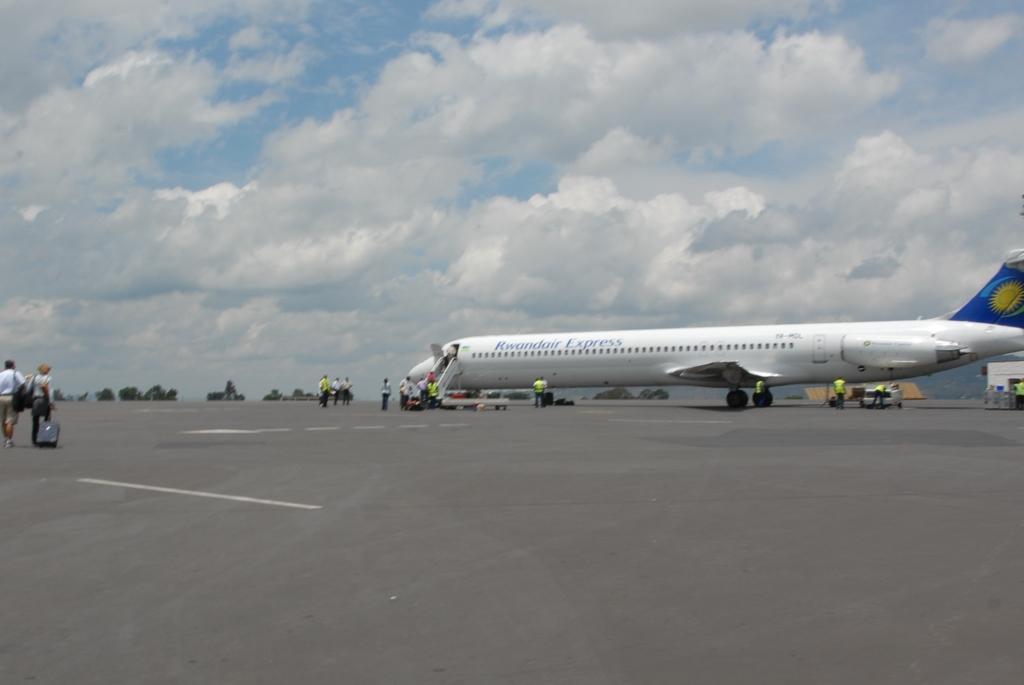Can you describe this image briefly? In this image we can see an aeroplane on the road. We can also see some people standing. On the backside we can see some trees and the sky which looks cloudy. 